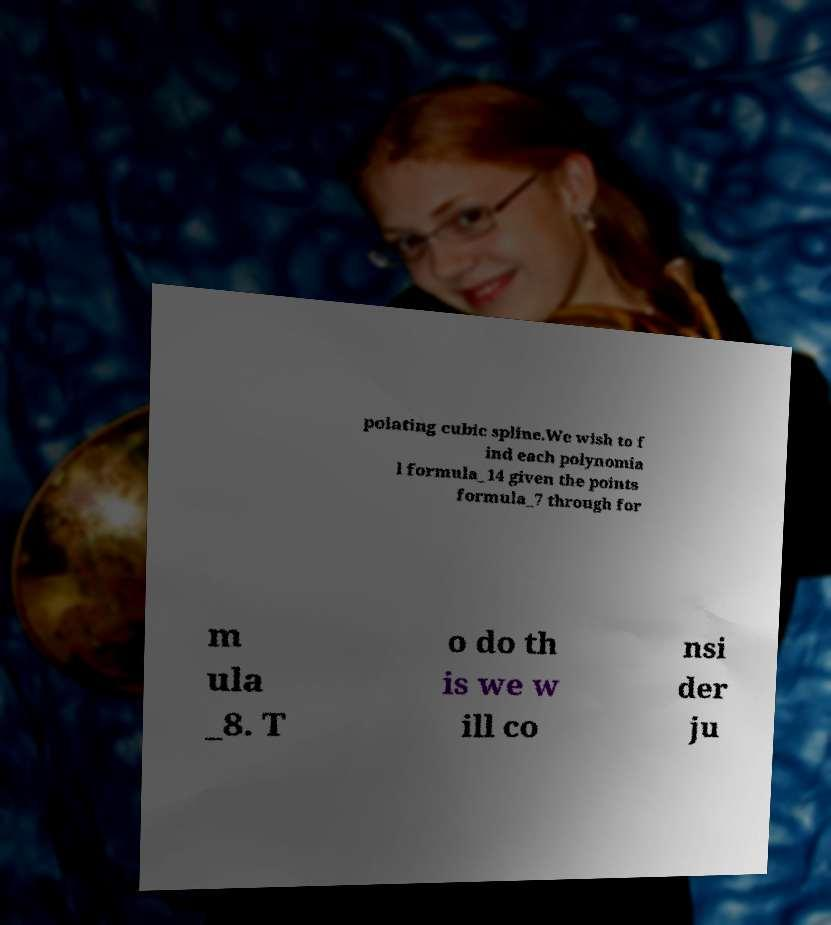Please read and relay the text visible in this image. What does it say? polating cubic spline.We wish to f ind each polynomia l formula_14 given the points formula_7 through for m ula _8. T o do th is we w ill co nsi der ju 